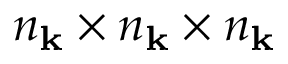<formula> <loc_0><loc_0><loc_500><loc_500>n _ { \mathbf k } \times n _ { \mathbf k } \times n _ { \mathbf k }</formula> 